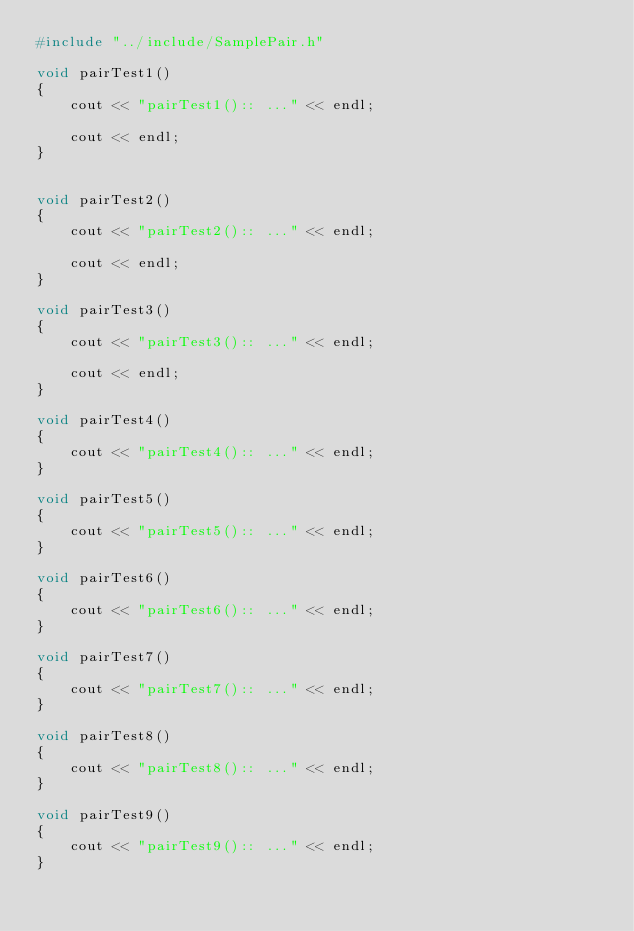Convert code to text. <code><loc_0><loc_0><loc_500><loc_500><_C++_>#include "../include/SamplePair.h"

void pairTest1()
{
    cout << "pairTest1():: ..." << endl;
    
    cout << endl;
}


void pairTest2()
{
    cout << "pairTest2():: ..." << endl;
   
    cout << endl;
}

void pairTest3()
{
    cout << "pairTest3():: ..." << endl;
  
    cout << endl;
}

void pairTest4()
{
    cout << "pairTest4():: ..." << endl;
}

void pairTest5()
{
    cout << "pairTest5():: ..." << endl;
}

void pairTest6()
{
    cout << "pairTest6():: ..." << endl;
}

void pairTest7()
{
    cout << "pairTest7():: ..." << endl;
}

void pairTest8()
{
    cout << "pairTest8():: ..." << endl;
}

void pairTest9()
{
    cout << "pairTest9():: ..." << endl;
}
</code> 